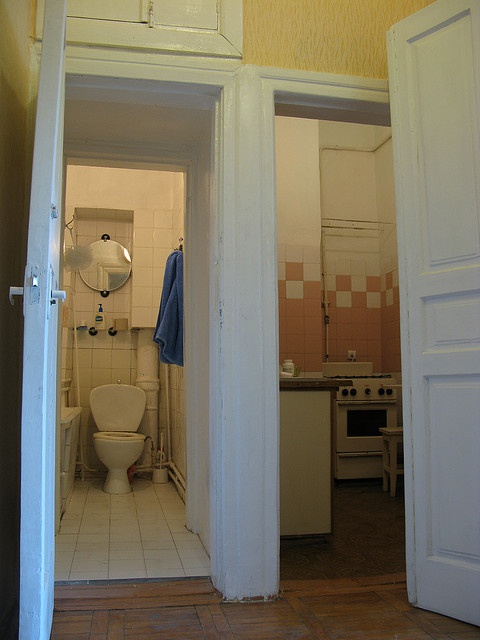Describe the objects in this image and their specific colors. I can see oven in black, maroon, and olive tones, toilet in olive tones, and chair in olive, black, maroon, and gray tones in this image. 